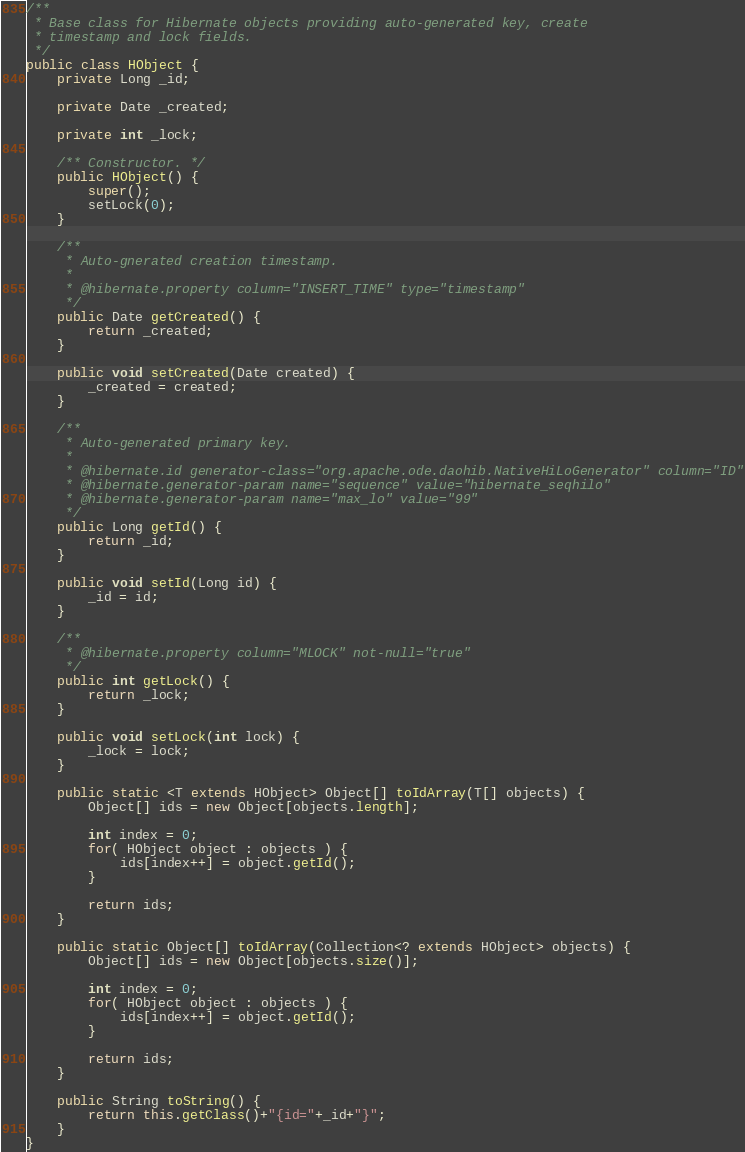<code> <loc_0><loc_0><loc_500><loc_500><_Java_>
/**
 * Base class for Hibernate objects providing auto-generated key, create
 * timestamp and lock fields.
 */
public class HObject {
    private Long _id;

    private Date _created;

    private int _lock;

    /** Constructor. */
    public HObject() {
        super();
        setLock(0);
    }

    /**
     * Auto-gnerated creation timestamp.
     *
     * @hibernate.property column="INSERT_TIME" type="timestamp"
     */
    public Date getCreated() {
        return _created;
    }

    public void setCreated(Date created) {
        _created = created;
    }

    /**
     * Auto-generated primary key.
     *
     * @hibernate.id generator-class="org.apache.ode.daohib.NativeHiLoGenerator" column="ID"
     * @hibernate.generator-param name="sequence" value="hibernate_seqhilo"
     * @hibernate.generator-param name="max_lo" value="99"
     */
    public Long getId() {
        return _id;
    }

    public void setId(Long id) {
        _id = id;
    }

    /**
     * @hibernate.property column="MLOCK" not-null="true"
     */
    public int getLock() {
        return _lock;
    }

    public void setLock(int lock) {
        _lock = lock;
    }

    public static <T extends HObject> Object[] toIdArray(T[] objects) {
        Object[] ids = new Object[objects.length];

        int index = 0;
        for( HObject object : objects ) {
            ids[index++] = object.getId();
        }

        return ids;
    }

    public static Object[] toIdArray(Collection<? extends HObject> objects) {
        Object[] ids = new Object[objects.size()];

        int index = 0;
        for( HObject object : objects ) {
            ids[index++] = object.getId();
        }

        return ids;
    }

    public String toString() {
        return this.getClass()+"{id="+_id+"}";
    }
}
</code> 